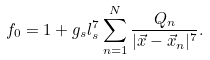Convert formula to latex. <formula><loc_0><loc_0><loc_500><loc_500>f _ { 0 } = 1 + g _ { s } l _ { s } ^ { 7 } \sum _ { n = 1 } ^ { N } \frac { Q _ { n } } { | \vec { x } - \vec { x } _ { n } | ^ { 7 } } .</formula> 